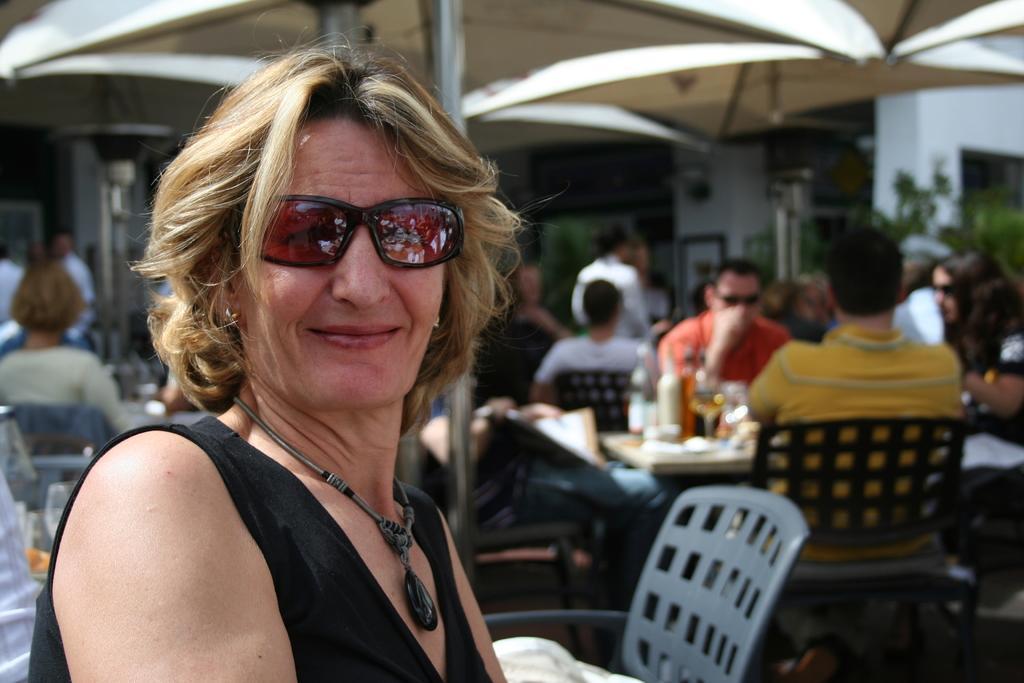Please provide a concise description of this image. In this picture we can see a woman wearing a black top and sunglasses smiling and giving a pose into the image. Behind we can see many people sitting on a chair and having lunch, Above we can see umbrella roofing. 